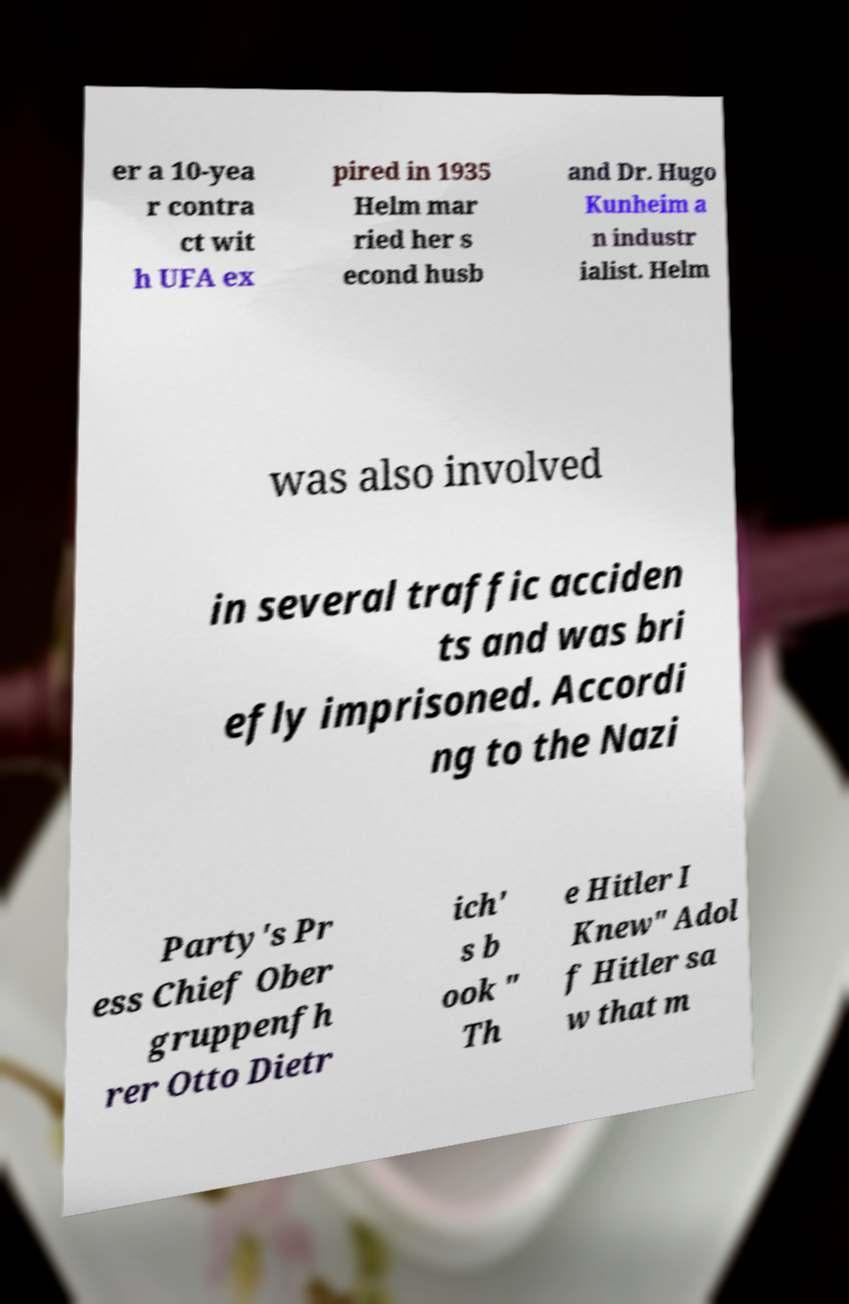Could you assist in decoding the text presented in this image and type it out clearly? er a 10-yea r contra ct wit h UFA ex pired in 1935 Helm mar ried her s econd husb and Dr. Hugo Kunheim a n industr ialist. Helm was also involved in several traffic acciden ts and was bri efly imprisoned. Accordi ng to the Nazi Party's Pr ess Chief Ober gruppenfh rer Otto Dietr ich' s b ook " Th e Hitler I Knew" Adol f Hitler sa w that m 